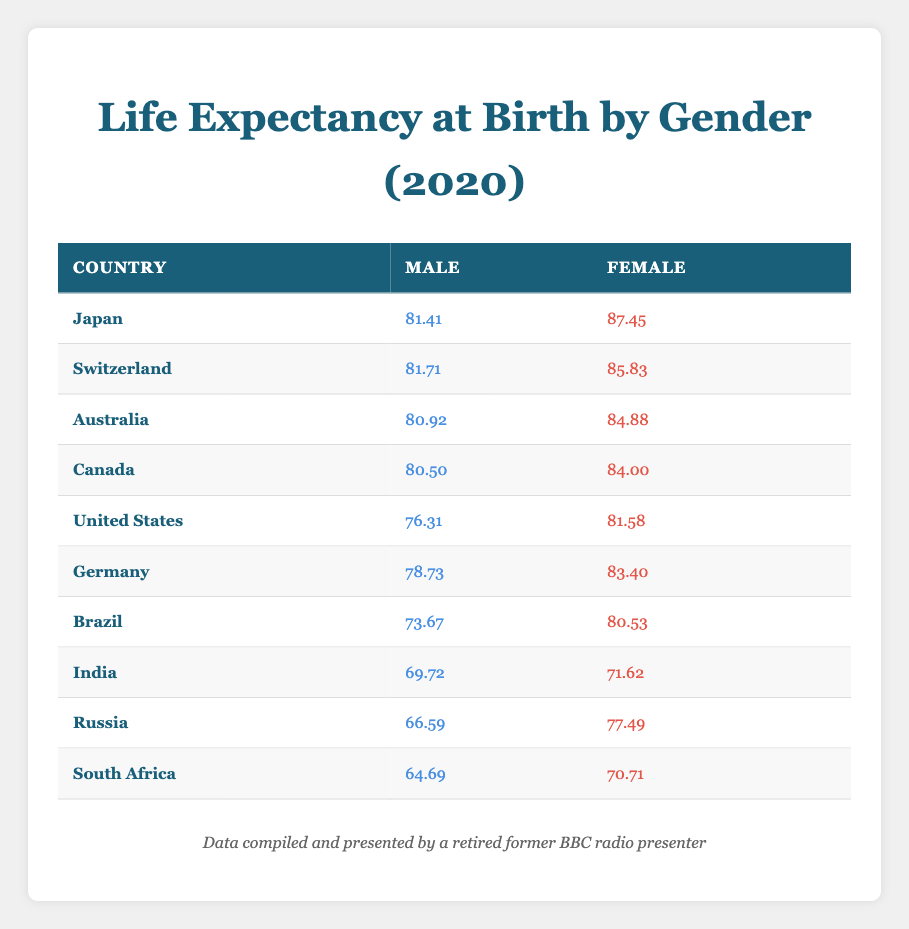What is the life expectancy at birth for females in Japan? From the table, we can see that Japan's female life expectancy is listed directly next to the country under the female column. It shows a value of 87.45.
Answer: 87.45 Which country has the highest male life expectancy? By scanning the male life expectancy values in the table, Switzerland has the highest value of 81.71, which is greater than all other countries listed.
Answer: Switzerland What is the difference in life expectancy at birth between males and females in Canada? In Canada, the male life expectancy is 80.50, and the female life expectancy is 84.00. Therefore, the difference is 84.00 - 80.50 = 3.50.
Answer: 3.50 Is it true that life expectancy for males is higher in Australia than in Brazil? Looking at the table, Australia has a male life expectancy of 80.92, while Brazil's is 73.67. Since 80.92 is greater than 73.67, the statement is true.
Answer: True What is the average life expectancy for females in the countries listed? To find the average female life expectancy, we sum the values for females: 87.45 + 85.83 + 84.88 + 84.00 + 81.58 + 83.40 + 80.53 + 71.62 + 77.49 + 70.71 = 835.39. There are 10 countries, so the average is 835.39 / 10 = 83.54.
Answer: 83.54 Which country has the lowest life expectancy at birth for both genders combined? The lowest male life expectancy is in South Africa at 64.69, and the lowest female life expectancy is in India at 71.62. Combining these values does not give a definitive answer, but among the overall values, South Africa has the lowest combined (64.69 for males and 70.71 for females = 135.40, which is lower than any other combined total).
Answer: South Africa What country has a higher life expectancy for females than Japan? The life expectancy for females in Japan is 87.45. Looking at the table, no other country has a female life expectancy higher than this value.
Answer: None What is the total life expectancy of males and females in Brazil? The male life expectancy in Brazil is 73.67 and the female is 80.53. The total life expectancy for both genders in Brazil would be the sum: 73.67 + 80.53 = 154.20.
Answer: 154.20 Are females expected to live longer in Russia than in South Africa? For Russia, the female life expectancy is 77.49 and for South Africa, it is 70.71. Since 77.49 is greater than 70.71, the answer is yes.
Answer: Yes 